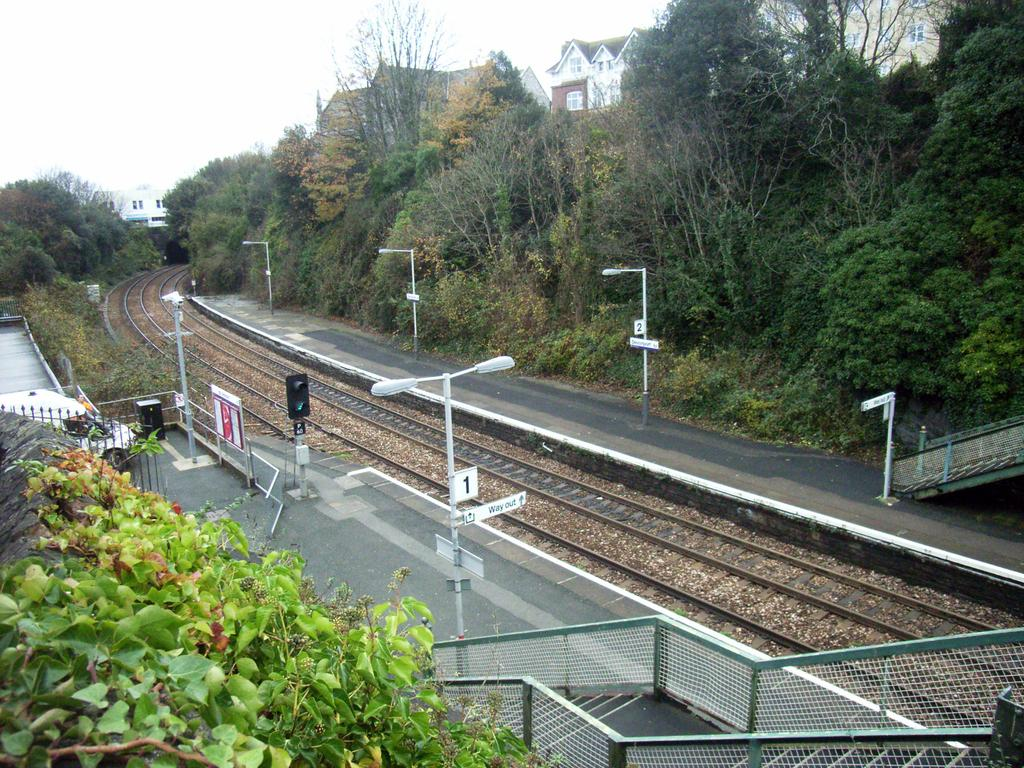What type of vegetation can be seen on the wall in the foreground? There are plants on the wall in the foreground. What structures can be seen in the background of the image? Poles, stairs, a railway track, a signal pole, trees, a side path, buildings, and the sky are visible in the background. Can you tell me how many times the person in the image expresses anger? There is no person present in the image, and therefore no expression of anger can be observed. What type of fire can be seen in the image? There is no fire present in the image. 